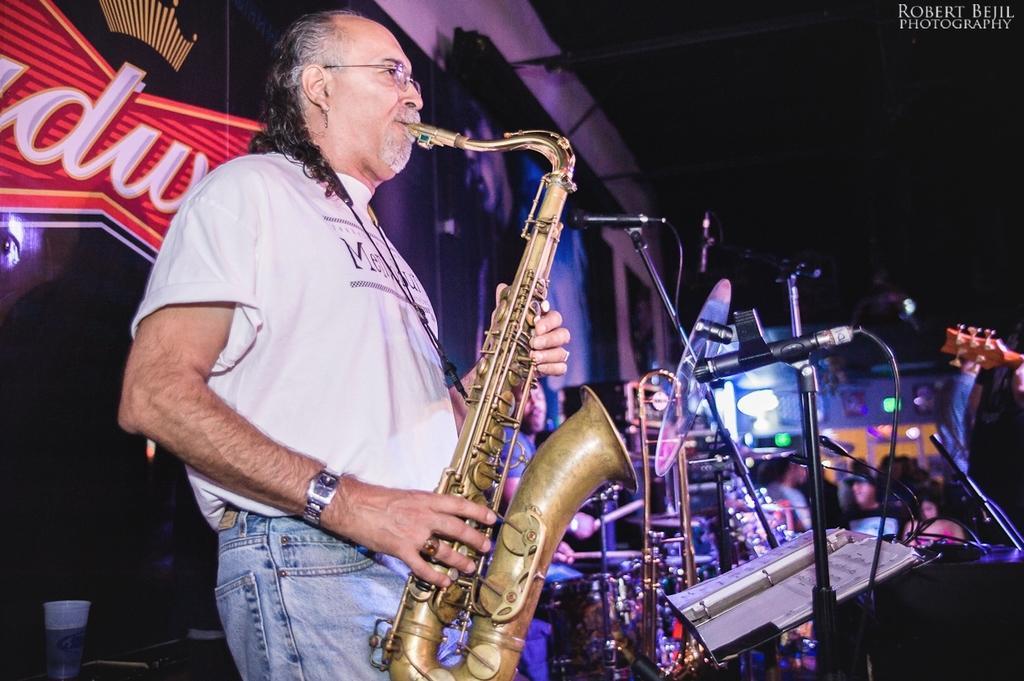Can you describe this image briefly? In this image I can see a person holding a musical instrument and in front of him I can see a mike and background is dark , on the left side I can see colorful board and glass visible at the bottom. in the top right there is a text. 